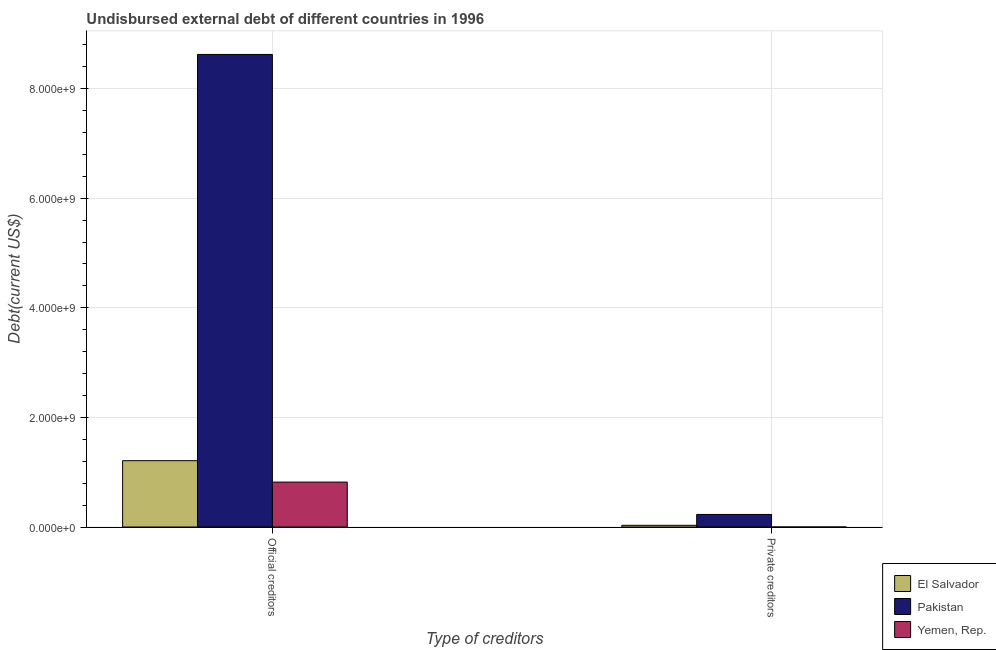How many different coloured bars are there?
Provide a short and direct response. 3. Are the number of bars per tick equal to the number of legend labels?
Keep it short and to the point. Yes. Are the number of bars on each tick of the X-axis equal?
Provide a short and direct response. Yes. How many bars are there on the 1st tick from the left?
Make the answer very short. 3. What is the label of the 1st group of bars from the left?
Your answer should be very brief. Official creditors. What is the undisbursed external debt of private creditors in Yemen, Rep.?
Offer a terse response. 1000. Across all countries, what is the maximum undisbursed external debt of private creditors?
Ensure brevity in your answer.  2.29e+08. Across all countries, what is the minimum undisbursed external debt of private creditors?
Provide a short and direct response. 1000. In which country was the undisbursed external debt of private creditors maximum?
Offer a terse response. Pakistan. In which country was the undisbursed external debt of private creditors minimum?
Offer a very short reply. Yemen, Rep. What is the total undisbursed external debt of official creditors in the graph?
Give a very brief answer. 1.07e+1. What is the difference between the undisbursed external debt of official creditors in Pakistan and that in Yemen, Rep.?
Your answer should be compact. 7.80e+09. What is the difference between the undisbursed external debt of official creditors in Yemen, Rep. and the undisbursed external debt of private creditors in El Salvador?
Your response must be concise. 7.89e+08. What is the average undisbursed external debt of private creditors per country?
Keep it short and to the point. 8.67e+07. What is the difference between the undisbursed external debt of private creditors and undisbursed external debt of official creditors in Yemen, Rep.?
Make the answer very short. -8.20e+08. What is the ratio of the undisbursed external debt of official creditors in El Salvador to that in Pakistan?
Provide a succinct answer. 0.14. What does the 1st bar from the left in Official creditors represents?
Provide a succinct answer. El Salvador. What does the 2nd bar from the right in Private creditors represents?
Your response must be concise. Pakistan. How many bars are there?
Your answer should be very brief. 6. What is the difference between two consecutive major ticks on the Y-axis?
Give a very brief answer. 2.00e+09. Are the values on the major ticks of Y-axis written in scientific E-notation?
Your answer should be compact. Yes. Where does the legend appear in the graph?
Offer a very short reply. Bottom right. How many legend labels are there?
Your answer should be very brief. 3. How are the legend labels stacked?
Ensure brevity in your answer.  Vertical. What is the title of the graph?
Offer a terse response. Undisbursed external debt of different countries in 1996. What is the label or title of the X-axis?
Provide a short and direct response. Type of creditors. What is the label or title of the Y-axis?
Offer a very short reply. Debt(current US$). What is the Debt(current US$) in El Salvador in Official creditors?
Your answer should be compact. 1.21e+09. What is the Debt(current US$) in Pakistan in Official creditors?
Provide a succinct answer. 8.62e+09. What is the Debt(current US$) of Yemen, Rep. in Official creditors?
Offer a very short reply. 8.20e+08. What is the Debt(current US$) of El Salvador in Private creditors?
Give a very brief answer. 3.11e+07. What is the Debt(current US$) of Pakistan in Private creditors?
Ensure brevity in your answer.  2.29e+08. What is the Debt(current US$) in Yemen, Rep. in Private creditors?
Provide a succinct answer. 1000. Across all Type of creditors, what is the maximum Debt(current US$) in El Salvador?
Your answer should be compact. 1.21e+09. Across all Type of creditors, what is the maximum Debt(current US$) of Pakistan?
Keep it short and to the point. 8.62e+09. Across all Type of creditors, what is the maximum Debt(current US$) of Yemen, Rep.?
Provide a short and direct response. 8.20e+08. Across all Type of creditors, what is the minimum Debt(current US$) in El Salvador?
Offer a terse response. 3.11e+07. Across all Type of creditors, what is the minimum Debt(current US$) in Pakistan?
Ensure brevity in your answer.  2.29e+08. Across all Type of creditors, what is the minimum Debt(current US$) in Yemen, Rep.?
Offer a terse response. 1000. What is the total Debt(current US$) of El Salvador in the graph?
Your answer should be very brief. 1.24e+09. What is the total Debt(current US$) of Pakistan in the graph?
Provide a short and direct response. 8.85e+09. What is the total Debt(current US$) of Yemen, Rep. in the graph?
Offer a very short reply. 8.20e+08. What is the difference between the Debt(current US$) of El Salvador in Official creditors and that in Private creditors?
Offer a very short reply. 1.18e+09. What is the difference between the Debt(current US$) of Pakistan in Official creditors and that in Private creditors?
Your answer should be compact. 8.39e+09. What is the difference between the Debt(current US$) of Yemen, Rep. in Official creditors and that in Private creditors?
Your answer should be very brief. 8.20e+08. What is the difference between the Debt(current US$) in El Salvador in Official creditors and the Debt(current US$) in Pakistan in Private creditors?
Ensure brevity in your answer.  9.81e+08. What is the difference between the Debt(current US$) in El Salvador in Official creditors and the Debt(current US$) in Yemen, Rep. in Private creditors?
Keep it short and to the point. 1.21e+09. What is the difference between the Debt(current US$) of Pakistan in Official creditors and the Debt(current US$) of Yemen, Rep. in Private creditors?
Offer a very short reply. 8.62e+09. What is the average Debt(current US$) in El Salvador per Type of creditors?
Provide a succinct answer. 6.21e+08. What is the average Debt(current US$) of Pakistan per Type of creditors?
Your answer should be compact. 4.43e+09. What is the average Debt(current US$) in Yemen, Rep. per Type of creditors?
Your response must be concise. 4.10e+08. What is the difference between the Debt(current US$) of El Salvador and Debt(current US$) of Pakistan in Official creditors?
Provide a succinct answer. -7.41e+09. What is the difference between the Debt(current US$) of El Salvador and Debt(current US$) of Yemen, Rep. in Official creditors?
Keep it short and to the point. 3.91e+08. What is the difference between the Debt(current US$) in Pakistan and Debt(current US$) in Yemen, Rep. in Official creditors?
Give a very brief answer. 7.80e+09. What is the difference between the Debt(current US$) in El Salvador and Debt(current US$) in Pakistan in Private creditors?
Your response must be concise. -1.98e+08. What is the difference between the Debt(current US$) of El Salvador and Debt(current US$) of Yemen, Rep. in Private creditors?
Give a very brief answer. 3.11e+07. What is the difference between the Debt(current US$) in Pakistan and Debt(current US$) in Yemen, Rep. in Private creditors?
Ensure brevity in your answer.  2.29e+08. What is the ratio of the Debt(current US$) in El Salvador in Official creditors to that in Private creditors?
Offer a very short reply. 38.86. What is the ratio of the Debt(current US$) in Pakistan in Official creditors to that in Private creditors?
Your answer should be compact. 37.66. What is the ratio of the Debt(current US$) of Yemen, Rep. in Official creditors to that in Private creditors?
Give a very brief answer. 8.20e+05. What is the difference between the highest and the second highest Debt(current US$) of El Salvador?
Keep it short and to the point. 1.18e+09. What is the difference between the highest and the second highest Debt(current US$) of Pakistan?
Offer a terse response. 8.39e+09. What is the difference between the highest and the second highest Debt(current US$) of Yemen, Rep.?
Offer a very short reply. 8.20e+08. What is the difference between the highest and the lowest Debt(current US$) of El Salvador?
Your answer should be very brief. 1.18e+09. What is the difference between the highest and the lowest Debt(current US$) in Pakistan?
Offer a terse response. 8.39e+09. What is the difference between the highest and the lowest Debt(current US$) of Yemen, Rep.?
Your response must be concise. 8.20e+08. 